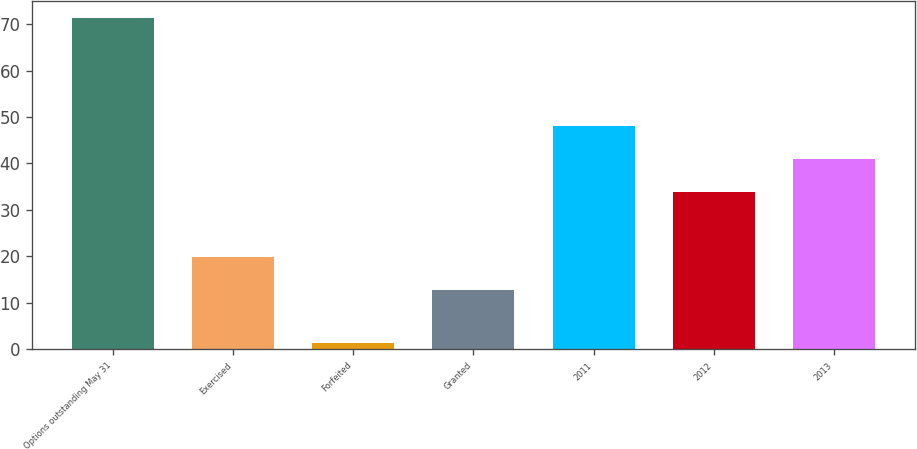<chart> <loc_0><loc_0><loc_500><loc_500><bar_chart><fcel>Options outstanding May 31<fcel>Exercised<fcel>Forfeited<fcel>Granted<fcel>2011<fcel>2012<fcel>2013<nl><fcel>71.39<fcel>19.79<fcel>1.3<fcel>12.7<fcel>48.08<fcel>33.9<fcel>40.99<nl></chart> 